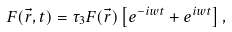Convert formula to latex. <formula><loc_0><loc_0><loc_500><loc_500>F ( \vec { r } , t ) = \tau _ { 3 } F ( \vec { r } ) \left [ e ^ { - i w t } + e ^ { i w t } \right ] ,</formula> 